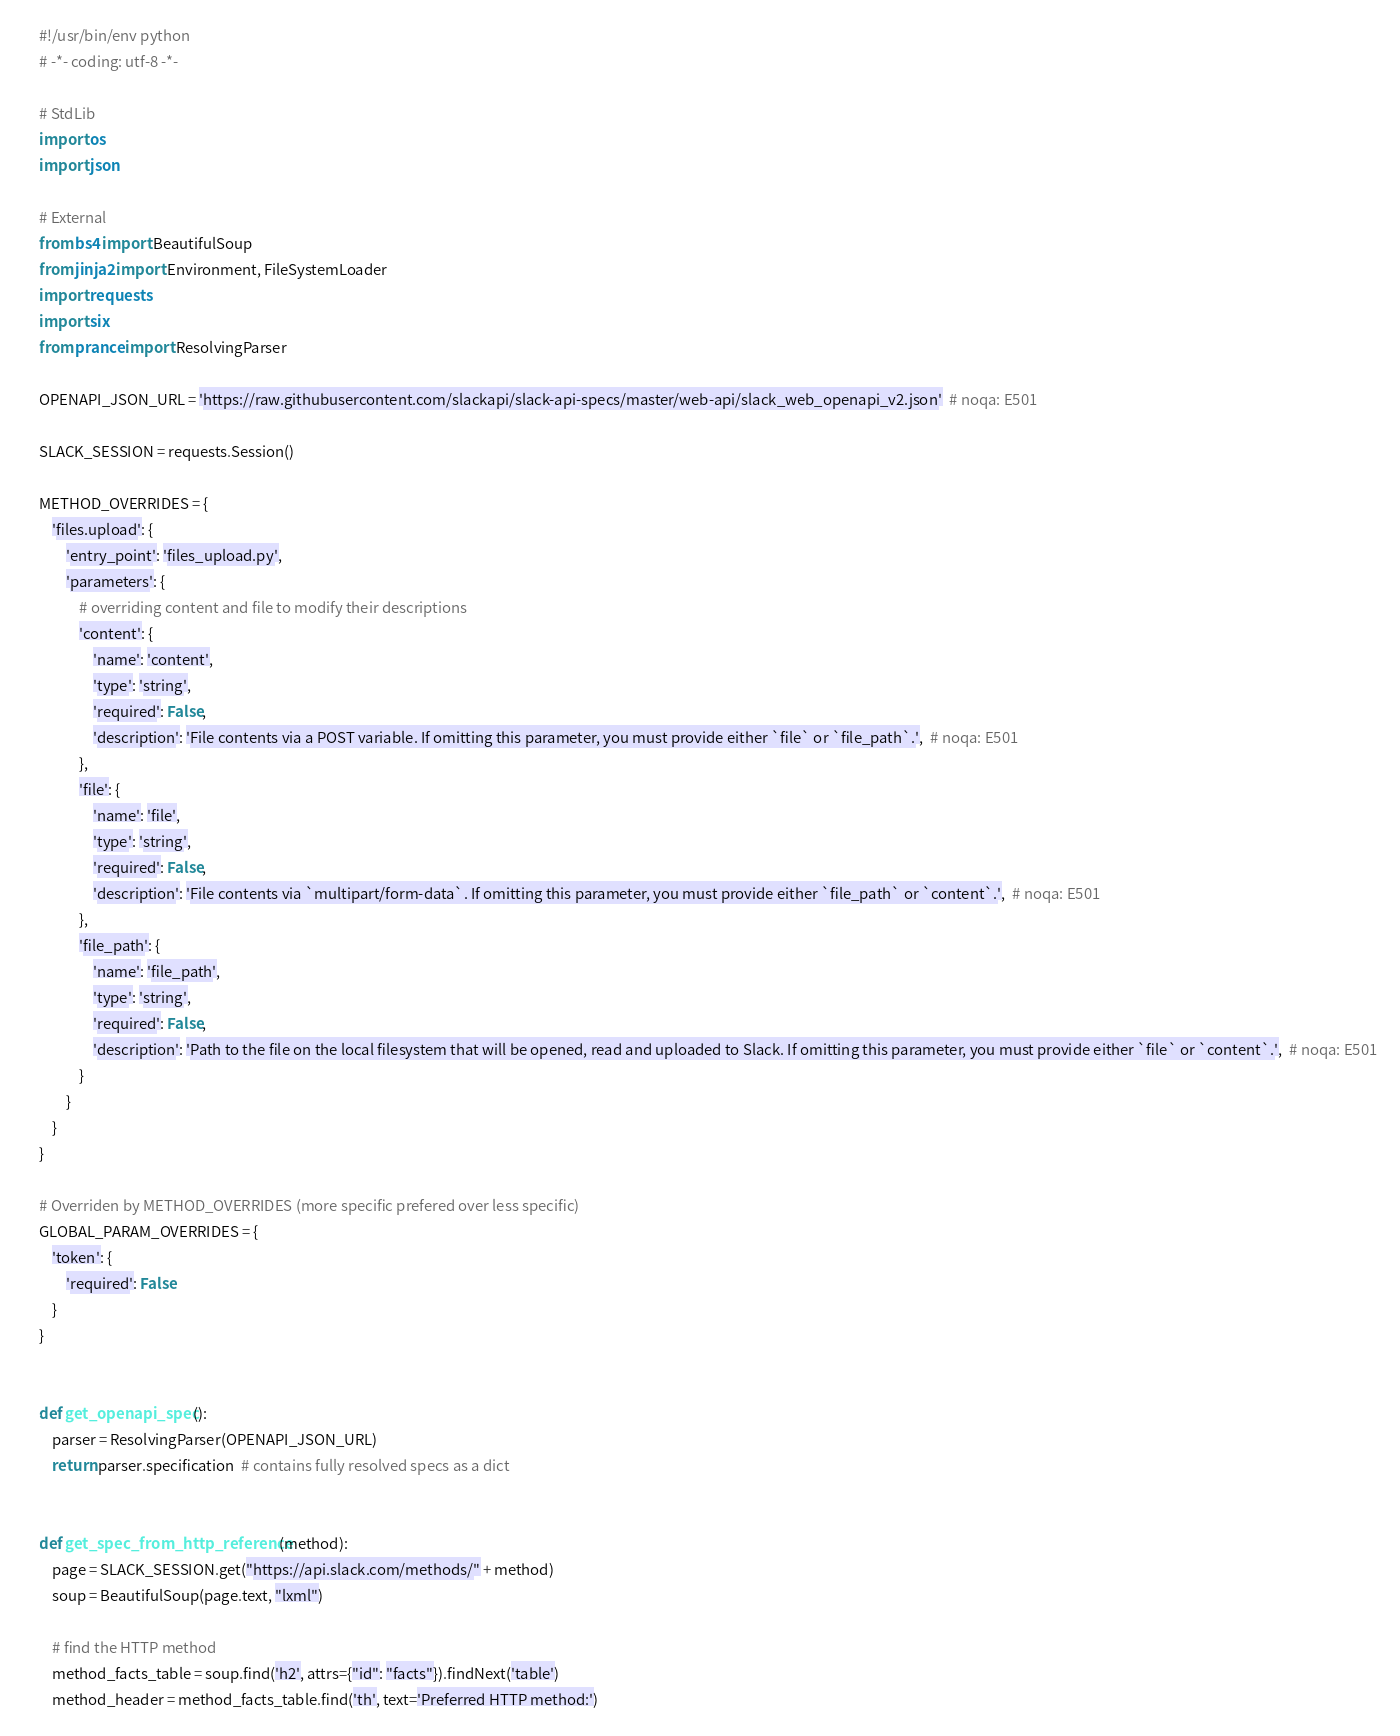Convert code to text. <code><loc_0><loc_0><loc_500><loc_500><_Python_>#!/usr/bin/env python
# -*- coding: utf-8 -*-

# StdLib
import os
import json

# External
from bs4 import BeautifulSoup
from jinja2 import Environment, FileSystemLoader
import requests
import six
from prance import ResolvingParser

OPENAPI_JSON_URL = 'https://raw.githubusercontent.com/slackapi/slack-api-specs/master/web-api/slack_web_openapi_v2.json'  # noqa: E501

SLACK_SESSION = requests.Session()

METHOD_OVERRIDES = {
    'files.upload': {
        'entry_point': 'files_upload.py',
        'parameters': {
            # overriding content and file to modify their descriptions
            'content': {
                'name': 'content',
                'type': 'string',
                'required': False,
                'description': 'File contents via a POST variable. If omitting this parameter, you must provide either `file` or `file_path`.',  # noqa: E501
            },
            'file': {
                'name': 'file',
                'type': 'string',
                'required': False,
                'description': 'File contents via `multipart/form-data`. If omitting this parameter, you must provide either `file_path` or `content`.',  # noqa: E501
            },
            'file_path': {
                'name': 'file_path',
                'type': 'string',
                'required': False,
                'description': 'Path to the file on the local filesystem that will be opened, read and uploaded to Slack. If omitting this parameter, you must provide either `file` or `content`.',  # noqa: E501
            }
        }
    }
}

# Overriden by METHOD_OVERRIDES (more specific prefered over less specific)
GLOBAL_PARAM_OVERRIDES = {
    'token': {
        'required': False
    }
}


def get_openapi_spec():
    parser = ResolvingParser(OPENAPI_JSON_URL)
    return parser.specification  # contains fully resolved specs as a dict


def get_spec_from_http_reference(method):
    page = SLACK_SESSION.get("https://api.slack.com/methods/" + method)
    soup = BeautifulSoup(page.text, "lxml")

    # find the HTTP method
    method_facts_table = soup.find('h2', attrs={"id": "facts"}).findNext('table')
    method_header = method_facts_table.find('th', text='Preferred HTTP method:')</code> 